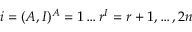Convert formula to latex. <formula><loc_0><loc_0><loc_500><loc_500>i = ( A , I ) ^ { A } = 1 \dots r ^ { I } = r + 1 , \dots , 2 n</formula> 